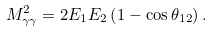Convert formula to latex. <formula><loc_0><loc_0><loc_500><loc_500>M ^ { 2 } _ { \gamma \gamma } = 2 E _ { 1 } E _ { 2 } \left ( 1 - \cos \theta _ { 1 2 } \right ) .</formula> 